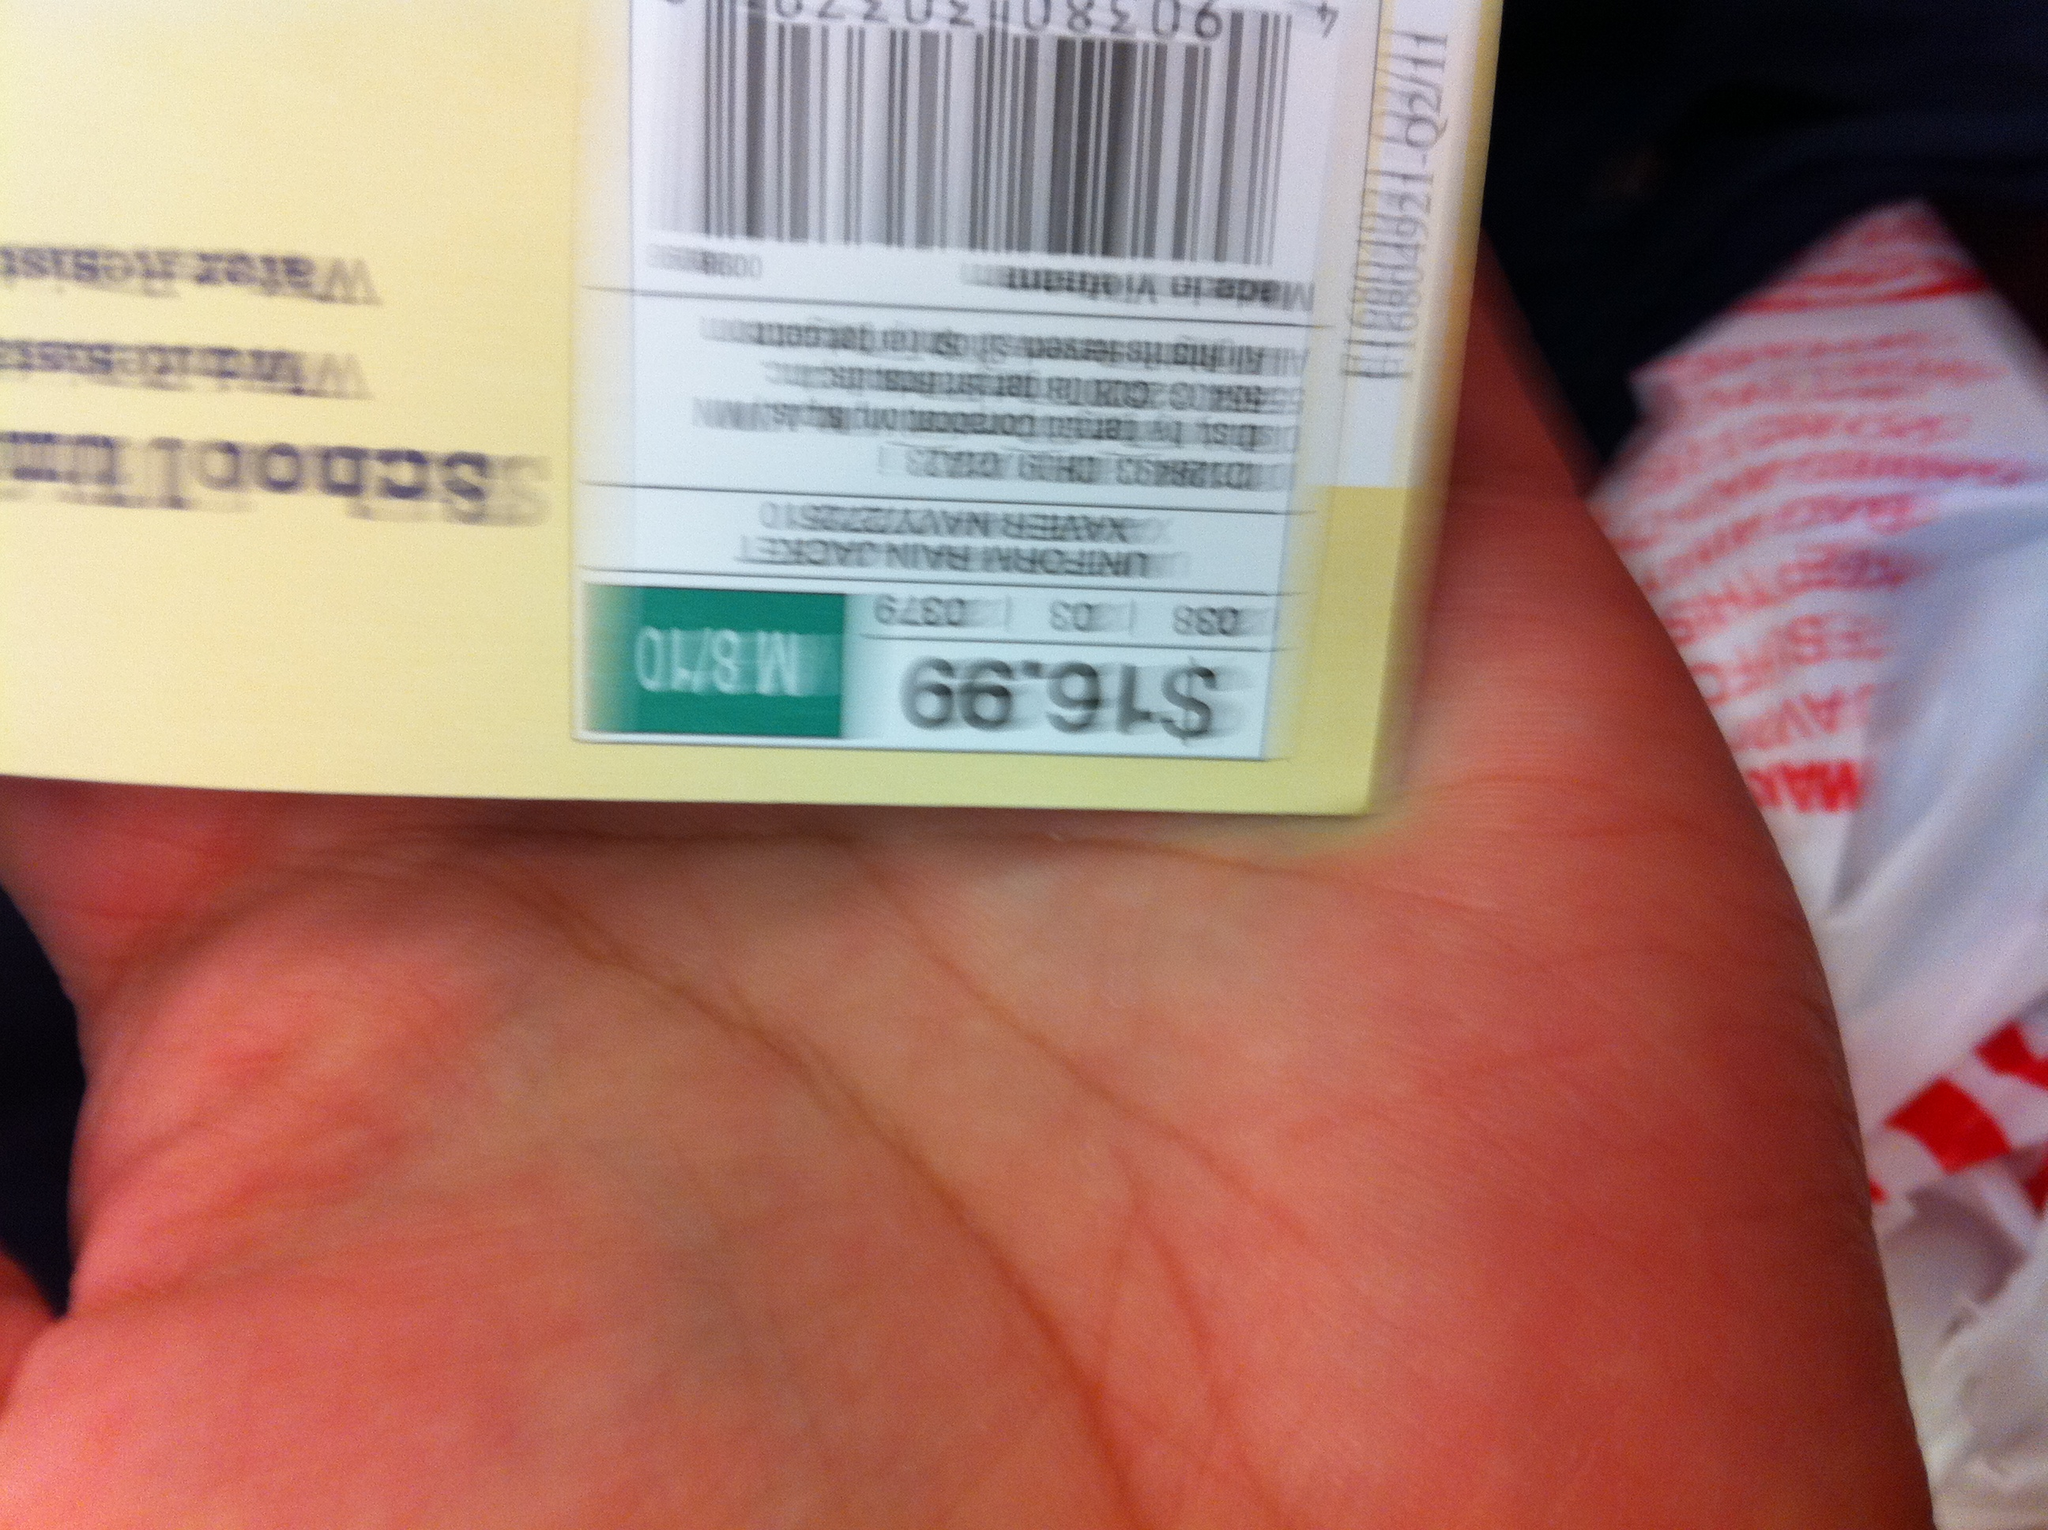Is there any other information on the tag that could be useful? Aside from the price, the tag includes a barcode that can be scanned for inventory tracking and point-of-sale transactions. It also appears to have a stock number or item code, which could be used to identify the item in a store or online catalogue. 